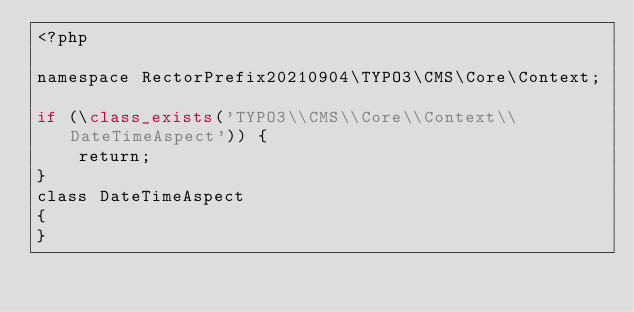Convert code to text. <code><loc_0><loc_0><loc_500><loc_500><_PHP_><?php

namespace RectorPrefix20210904\TYPO3\CMS\Core\Context;

if (\class_exists('TYPO3\\CMS\\Core\\Context\\DateTimeAspect')) {
    return;
}
class DateTimeAspect
{
}
</code> 